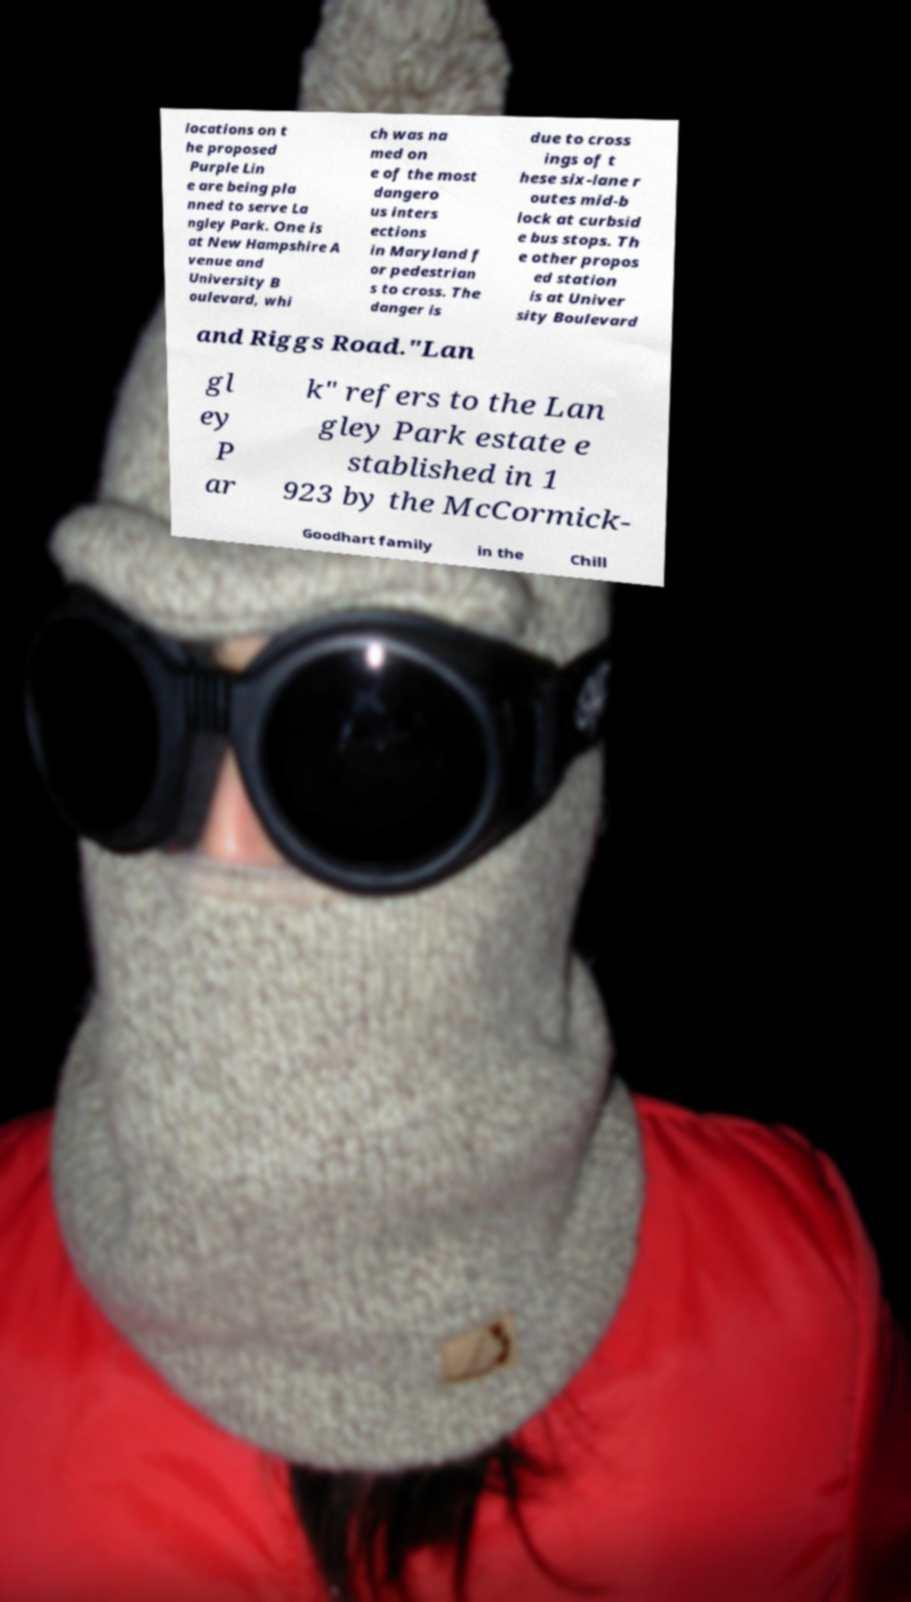Please read and relay the text visible in this image. What does it say? locations on t he proposed Purple Lin e are being pla nned to serve La ngley Park. One is at New Hampshire A venue and University B oulevard, whi ch was na med on e of the most dangero us inters ections in Maryland f or pedestrian s to cross. The danger is due to cross ings of t hese six-lane r outes mid-b lock at curbsid e bus stops. Th e other propos ed station is at Univer sity Boulevard and Riggs Road."Lan gl ey P ar k" refers to the Lan gley Park estate e stablished in 1 923 by the McCormick- Goodhart family in the Chill 